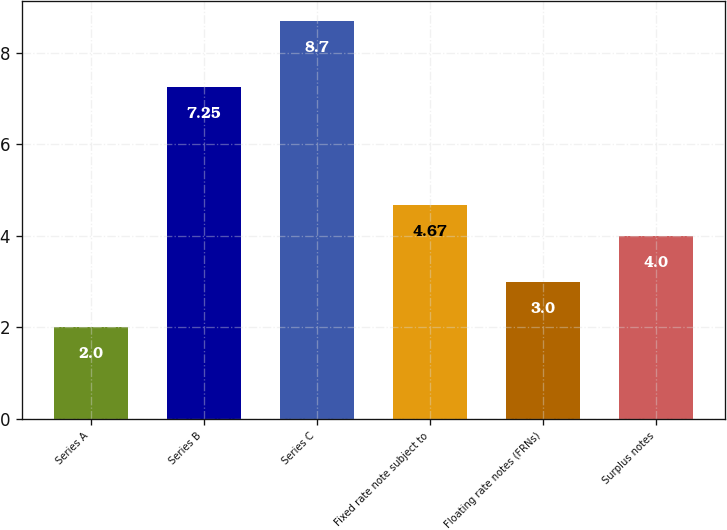<chart> <loc_0><loc_0><loc_500><loc_500><bar_chart><fcel>Series A<fcel>Series B<fcel>Series C<fcel>Fixed rate note subject to<fcel>Floating rate notes (FRNs)<fcel>Surplus notes<nl><fcel>2<fcel>7.25<fcel>8.7<fcel>4.67<fcel>3<fcel>4<nl></chart> 